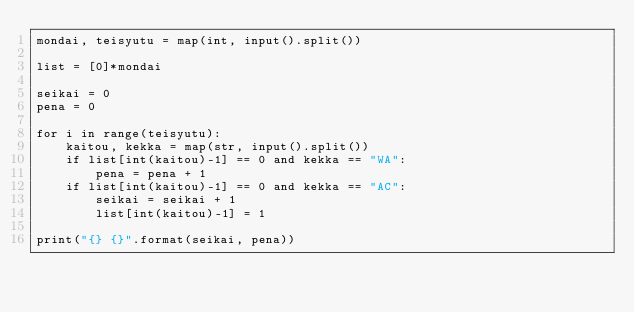<code> <loc_0><loc_0><loc_500><loc_500><_Python_>mondai, teisyutu = map(int, input().split())

list = [0]*mondai

seikai = 0
pena = 0

for i in range(teisyutu):
    kaitou, kekka = map(str, input().split())
    if list[int(kaitou)-1] == 0 and kekka == "WA":
        pena = pena + 1
    if list[int(kaitou)-1] == 0 and kekka == "AC":
        seikai = seikai + 1
        list[int(kaitou)-1] = 1

print("{} {}".format(seikai, pena))</code> 